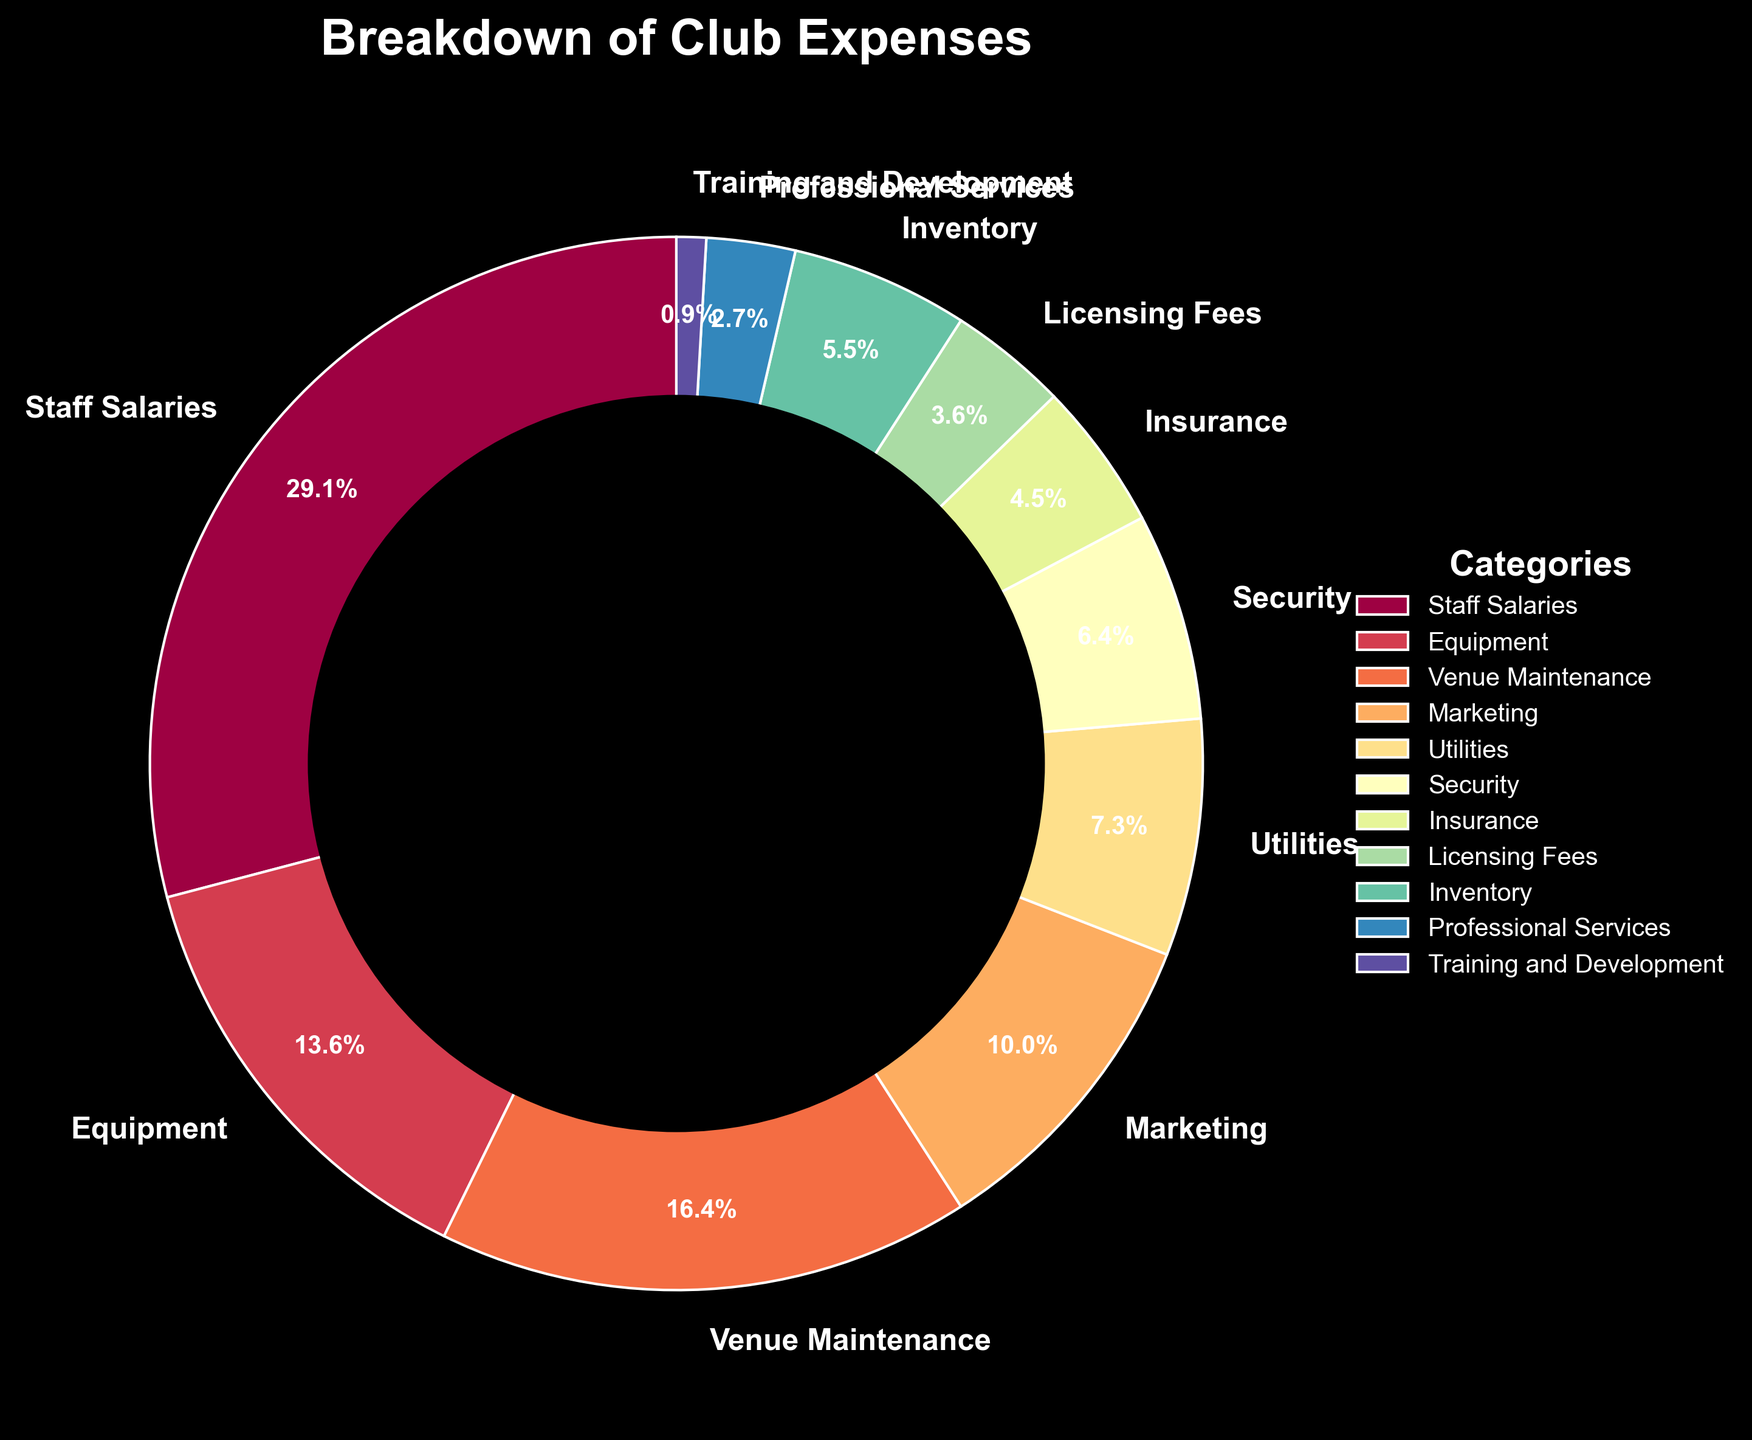What is the largest category of expenses in the club's budget? The largest category of expenses can be identified by looking for the segment with the highest percentage in the pie chart. The "Staff Salaries" segment is the largest at 32%.
Answer: Staff Salaries What is the combined percentage of equipment and professional services expenses? To find the combined percentage, add the percentages of "Equipment" and "Professional Services." Equipment is 15% and Professional Services is 3%. Therefore, the combined percentage is 15% + 3% = 18%.
Answer: 18% How does the percentage for venue maintenance compare to inventory? Compare the percentage of "Venue Maintenance" and "Inventory" segments. Venue Maintenance is 18% while Inventory is 6%, therefore Venue Maintenance has a higher percentage than Inventory.
Answer: Venue Maintenance has a higher percentage Which category has a lower percentage, security or licensing fees? Compare the percentages of "Security" and "Licensing Fees" segments. Security is 7% and Licensing Fees is 4%. Licensing Fees is lower.
Answer: Licensing Fees Which categories together make up more than half of the expenses? To find which categories together make up more than 50% of the expenses, add the percentages from the largest until the sum exceeds 50%. 
32% (Staff Salaries) + 18% (Venue Maintenance) = 50%, exceeds 50%. Therefore, Staff Salaries and Venue Maintenance make up more than half the expenses.
Answer: Staff Salaries and Venue Maintenance What is the difference in percentage between marketing and utilities? Subtract the percentage of "Utilities" from "Marketing". Marketing is 11% and Utilities is 8%. Therefore, the difference is 11% - 8% = 3%.
Answer: 3% Is the combined percentage of insurance and licensing fees higher or lower than marketing? Add the percentages of "Insurance" and "Licensing Fees" and compare with "Marketing." Insurance is 5% and Licensing Fees is 4%, so combined is 5% + 4% = 9%. Marketing is 11%, so the combined percentage of Insurance and Licensing Fees is lower than Marketing.
Answer: Lower By how much does the percentage for staff salaries exceed the combined percentage of inventory and insurance? First, find the combined percentage of Inventory and Insurance by adding them: 6% (Inventory) + 5% (Insurance) = 11%. Then subtract this combined percentage from Staff Salaries: 32% (Staff Salaries) - 11% = 21%.
Answer: 21% What percentage of the expenses are allocated to categories with less than 5% each? Identify categories with less than 5% each and sum their percentages. Licensing Fees (4%), Professional Services (3%), and Training and Development (1%). The total is 4% + 3% + 1% = 8%.
Answer: 8% Which category has the smallest portion of the club’s expenses? Identify the segment with the smallest percentage. The category with the smallest portion is "Training and Development" with 1%.
Answer: Training and Development 